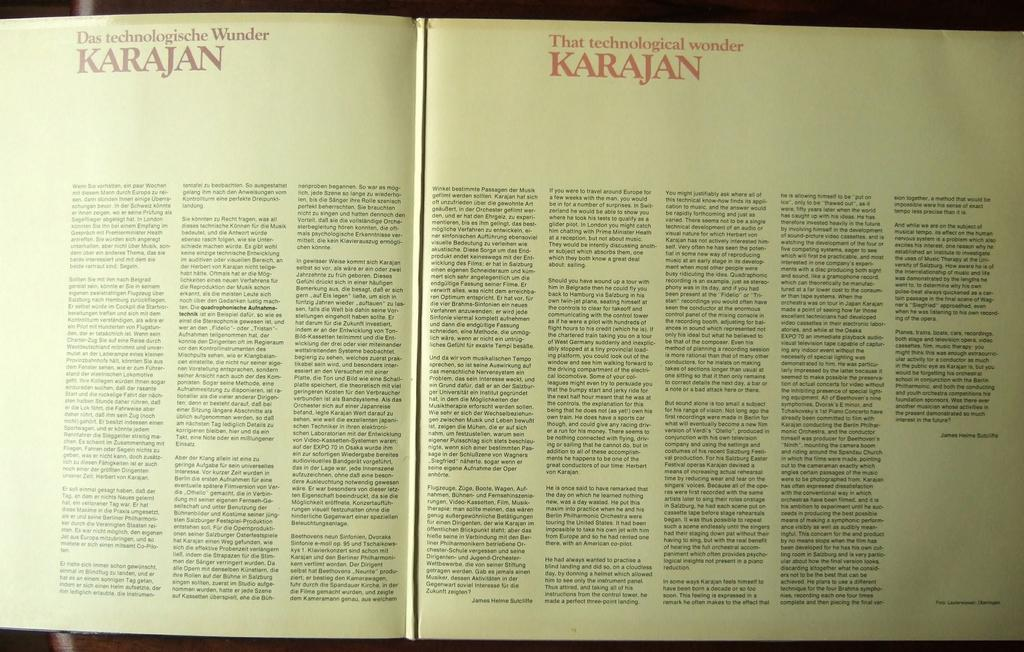<image>
Create a compact narrative representing the image presented. A text in German and English is about the technological wonder Karajan. 